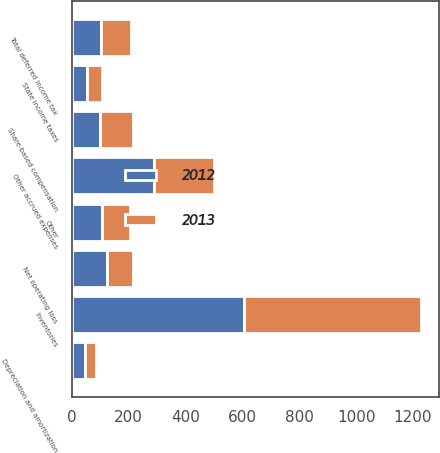<chart> <loc_0><loc_0><loc_500><loc_500><stacked_bar_chart><ecel><fcel>Inventories<fcel>Other accrued expenses<fcel>Depreciation and amortization<fcel>State income taxes<fcel>Share-based compensation<fcel>Net operating loss<fcel>Other<fcel>Total deferred income tax<nl><fcel>2012<fcel>607<fcel>288<fcel>46<fcel>53<fcel>101<fcel>124<fcel>107<fcel>104<nl><fcel>2013<fcel>623<fcel>212<fcel>41<fcel>54<fcel>115<fcel>90<fcel>97<fcel>104<nl></chart> 